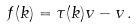Convert formula to latex. <formula><loc_0><loc_0><loc_500><loc_500>f ( k ) = \tau ( k ) v - v \, .</formula> 